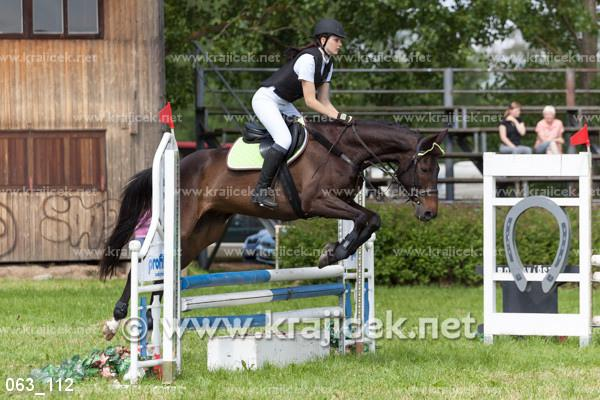What kind of horseback riding style is this?

Choices:
A) western
B) arabian
C) english
D) group english 